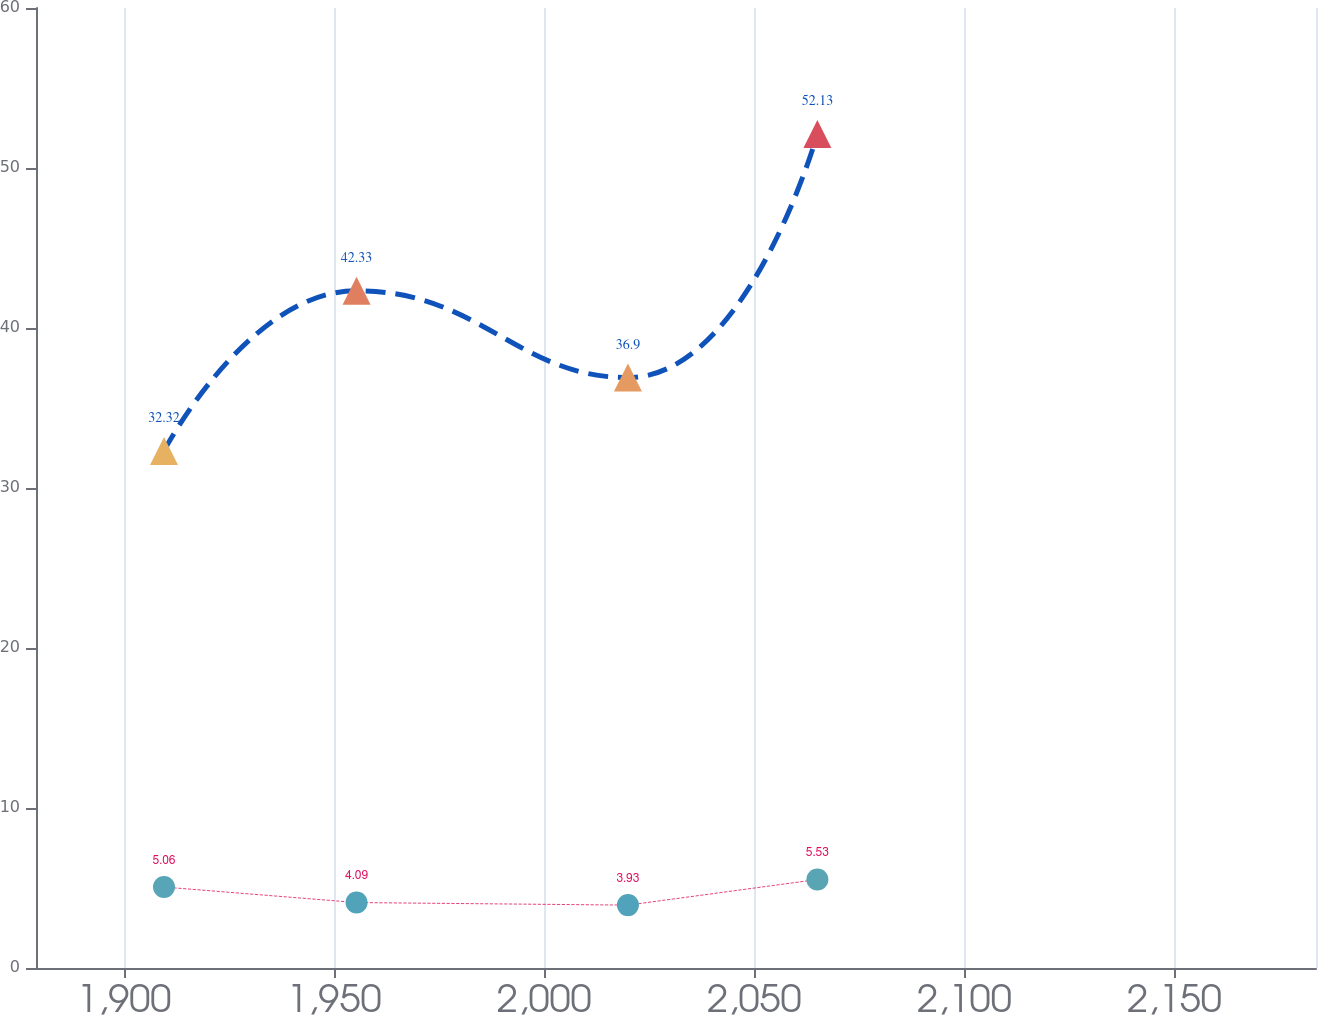<chart> <loc_0><loc_0><loc_500><loc_500><line_chart><ecel><fcel>Retiree Medical Plans<fcel>Pension Plans<nl><fcel>1909.51<fcel>32.32<fcel>5.06<nl><fcel>1955.34<fcel>42.33<fcel>4.09<nl><fcel>2019.93<fcel>36.9<fcel>3.93<nl><fcel>2065.02<fcel>52.13<fcel>5.53<nl><fcel>2214.16<fcel>38.96<fcel>4.34<nl></chart> 